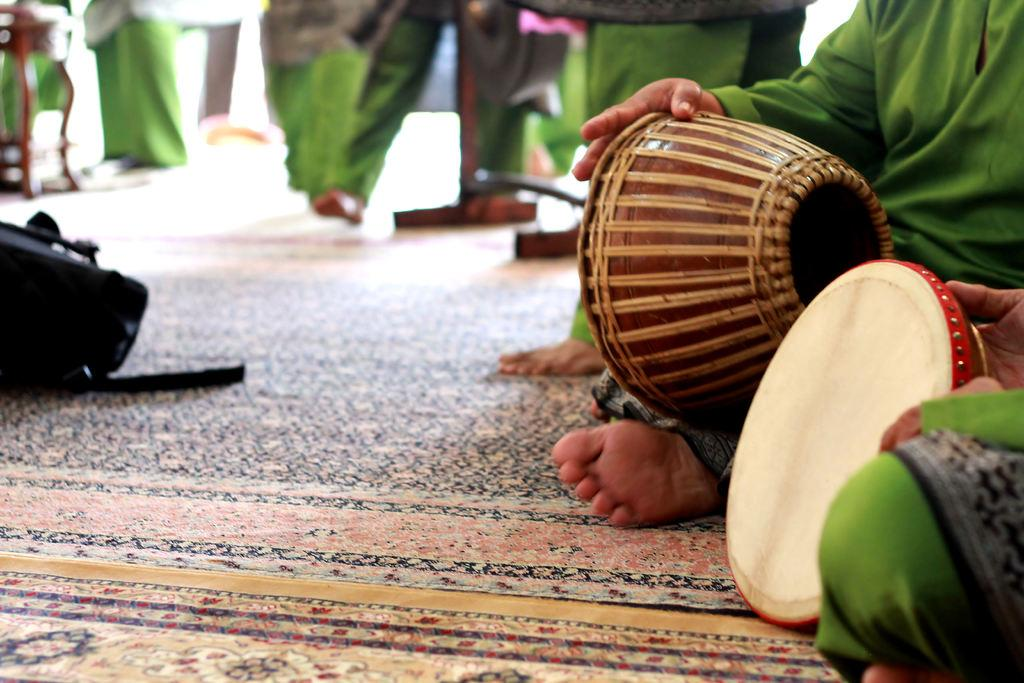Who or what is present in the image? There is a person in the image. Where is the person located in the image? The person is sitting at the right side of the image. What is the person holding in his hands? The person is holding a tabla in his hands. What type of square can be seen in the image? There is no square present in the image. How many roses are visible in the image? There are no roses present in the image. 